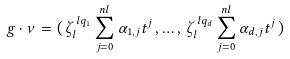<formula> <loc_0><loc_0><loc_500><loc_500>g \cdot \nu = ( \, \zeta _ { l } ^ { \, l q _ { 1 } } \sum _ { j = 0 } ^ { n l } \alpha _ { 1 , j } t ^ { j } \, , \dots , \, \zeta _ { l } ^ { \, l q _ { d } } \sum _ { j = 0 } ^ { n l } \alpha _ { d , j } t ^ { j } \, )</formula> 